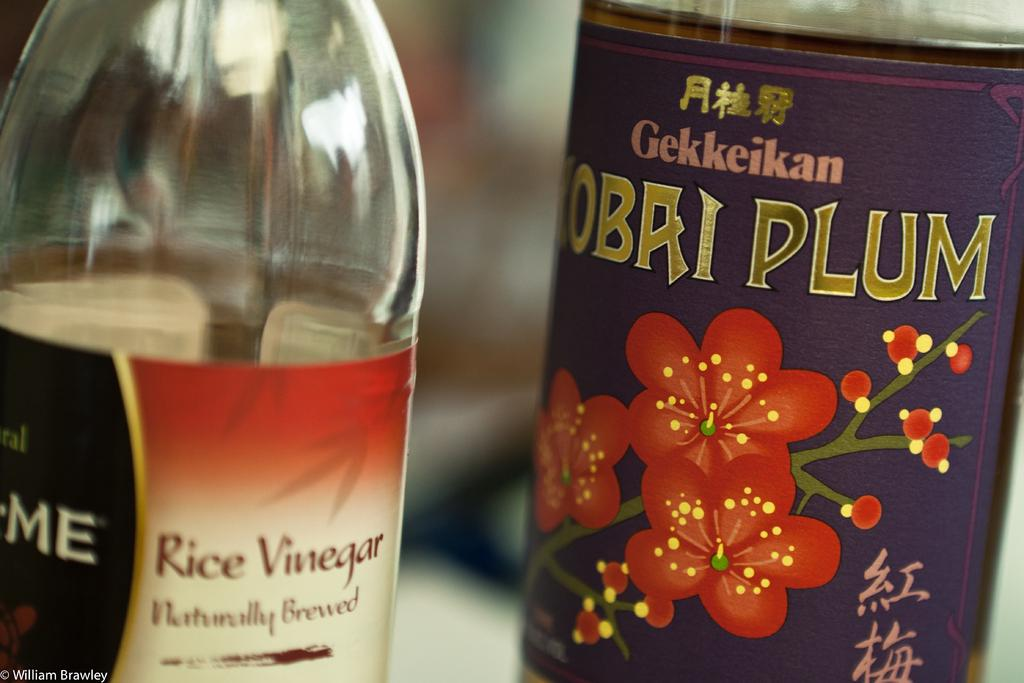<image>
Summarize the visual content of the image. A bottle of rice vinegar and plum wine sit side by side. 